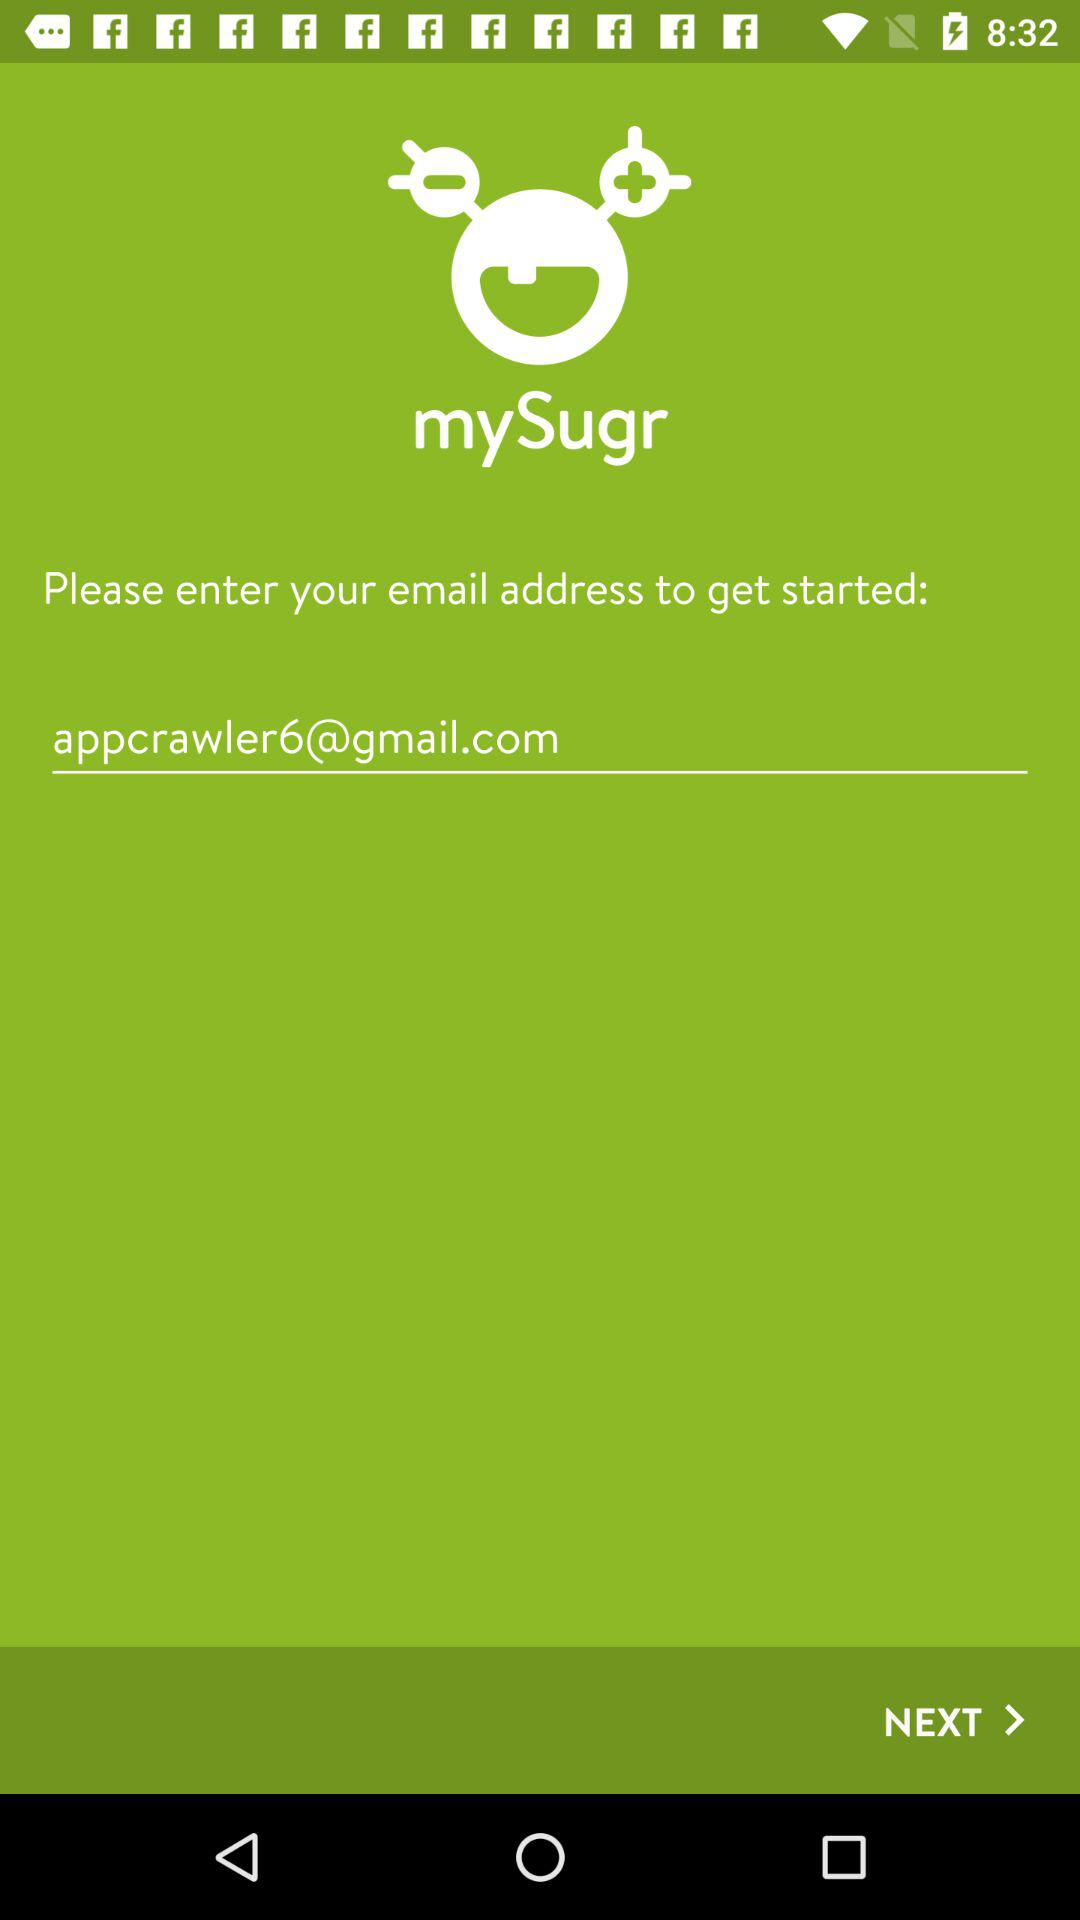How many input fields are on this screen?
Answer the question using a single word or phrase. 1 